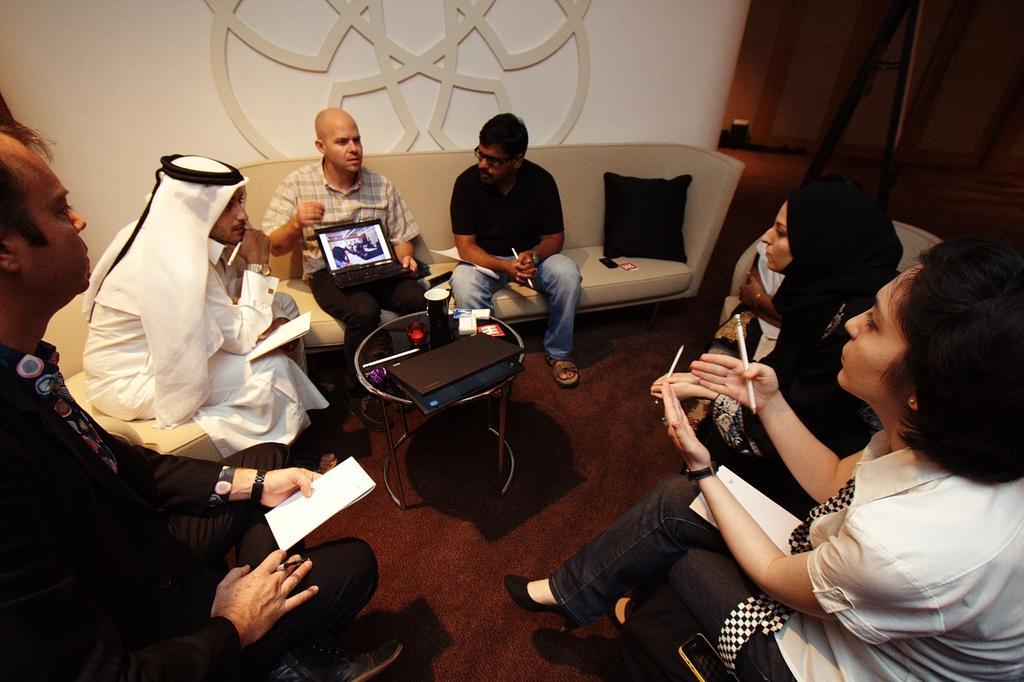Could you give a brief overview of what you see in this image? people are sitting. in the center there is a table on which there are glasses and a laptop. in the front people are holding papers in their hand. in the center behind there is a person holding laptop. behind him there is a white wall. 